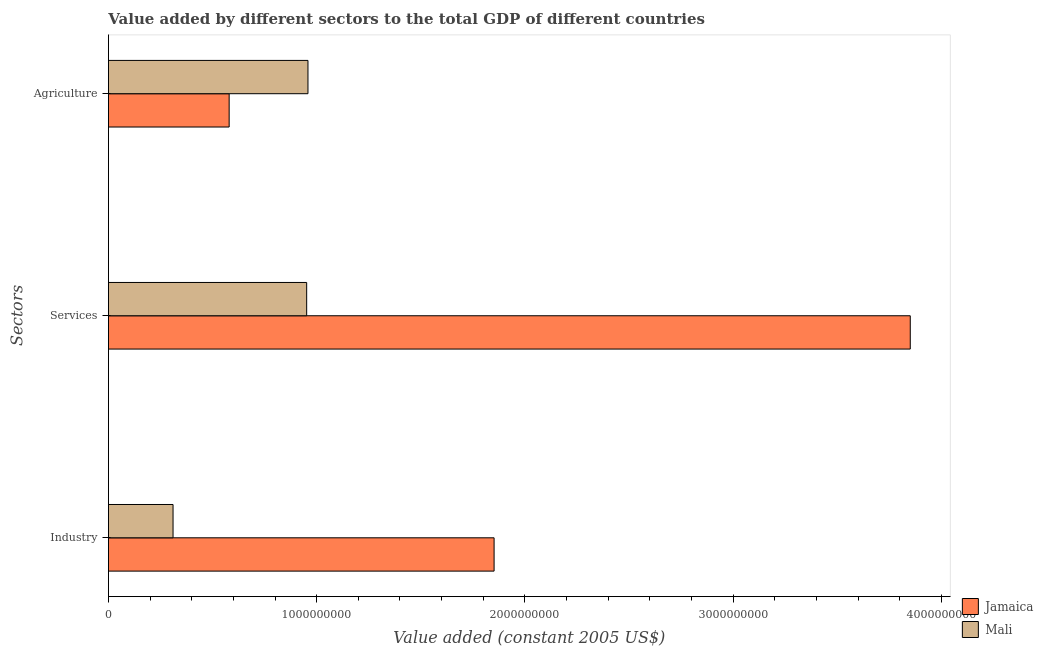Are the number of bars on each tick of the Y-axis equal?
Your answer should be compact. Yes. How many bars are there on the 3rd tick from the bottom?
Offer a terse response. 2. What is the label of the 1st group of bars from the top?
Provide a succinct answer. Agriculture. What is the value added by industrial sector in Jamaica?
Offer a very short reply. 1.85e+09. Across all countries, what is the maximum value added by agricultural sector?
Provide a succinct answer. 9.58e+08. Across all countries, what is the minimum value added by industrial sector?
Give a very brief answer. 3.10e+08. In which country was the value added by agricultural sector maximum?
Your response must be concise. Mali. In which country was the value added by services minimum?
Your response must be concise. Mali. What is the total value added by agricultural sector in the graph?
Your answer should be very brief. 1.54e+09. What is the difference between the value added by services in Jamaica and that in Mali?
Ensure brevity in your answer.  2.90e+09. What is the difference between the value added by agricultural sector in Jamaica and the value added by services in Mali?
Keep it short and to the point. -3.72e+08. What is the average value added by services per country?
Make the answer very short. 2.40e+09. What is the difference between the value added by agricultural sector and value added by industrial sector in Jamaica?
Provide a succinct answer. -1.27e+09. What is the ratio of the value added by agricultural sector in Mali to that in Jamaica?
Ensure brevity in your answer.  1.65. Is the difference between the value added by agricultural sector in Jamaica and Mali greater than the difference between the value added by services in Jamaica and Mali?
Give a very brief answer. No. What is the difference between the highest and the second highest value added by agricultural sector?
Offer a terse response. 3.78e+08. What is the difference between the highest and the lowest value added by agricultural sector?
Ensure brevity in your answer.  3.78e+08. What does the 2nd bar from the top in Agriculture represents?
Make the answer very short. Jamaica. What does the 1st bar from the bottom in Services represents?
Provide a succinct answer. Jamaica. How many bars are there?
Your response must be concise. 6. Are all the bars in the graph horizontal?
Your response must be concise. Yes. How many countries are there in the graph?
Make the answer very short. 2. What is the difference between two consecutive major ticks on the X-axis?
Give a very brief answer. 1.00e+09. Are the values on the major ticks of X-axis written in scientific E-notation?
Your response must be concise. No. Does the graph contain grids?
Keep it short and to the point. No. How many legend labels are there?
Provide a succinct answer. 2. How are the legend labels stacked?
Your response must be concise. Vertical. What is the title of the graph?
Provide a succinct answer. Value added by different sectors to the total GDP of different countries. What is the label or title of the X-axis?
Your response must be concise. Value added (constant 2005 US$). What is the label or title of the Y-axis?
Provide a succinct answer. Sectors. What is the Value added (constant 2005 US$) of Jamaica in Industry?
Your answer should be very brief. 1.85e+09. What is the Value added (constant 2005 US$) in Mali in Industry?
Your response must be concise. 3.10e+08. What is the Value added (constant 2005 US$) in Jamaica in Services?
Make the answer very short. 3.85e+09. What is the Value added (constant 2005 US$) in Mali in Services?
Give a very brief answer. 9.52e+08. What is the Value added (constant 2005 US$) in Jamaica in Agriculture?
Ensure brevity in your answer.  5.80e+08. What is the Value added (constant 2005 US$) in Mali in Agriculture?
Provide a succinct answer. 9.58e+08. Across all Sectors, what is the maximum Value added (constant 2005 US$) of Jamaica?
Keep it short and to the point. 3.85e+09. Across all Sectors, what is the maximum Value added (constant 2005 US$) of Mali?
Your answer should be compact. 9.58e+08. Across all Sectors, what is the minimum Value added (constant 2005 US$) in Jamaica?
Make the answer very short. 5.80e+08. Across all Sectors, what is the minimum Value added (constant 2005 US$) in Mali?
Ensure brevity in your answer.  3.10e+08. What is the total Value added (constant 2005 US$) of Jamaica in the graph?
Offer a terse response. 6.28e+09. What is the total Value added (constant 2005 US$) of Mali in the graph?
Provide a succinct answer. 2.22e+09. What is the difference between the Value added (constant 2005 US$) in Jamaica in Industry and that in Services?
Your answer should be very brief. -2.00e+09. What is the difference between the Value added (constant 2005 US$) of Mali in Industry and that in Services?
Offer a very short reply. -6.42e+08. What is the difference between the Value added (constant 2005 US$) of Jamaica in Industry and that in Agriculture?
Provide a succinct answer. 1.27e+09. What is the difference between the Value added (constant 2005 US$) in Mali in Industry and that in Agriculture?
Your response must be concise. -6.48e+08. What is the difference between the Value added (constant 2005 US$) in Jamaica in Services and that in Agriculture?
Make the answer very short. 3.27e+09. What is the difference between the Value added (constant 2005 US$) of Mali in Services and that in Agriculture?
Offer a terse response. -6.18e+06. What is the difference between the Value added (constant 2005 US$) in Jamaica in Industry and the Value added (constant 2005 US$) in Mali in Services?
Make the answer very short. 9.00e+08. What is the difference between the Value added (constant 2005 US$) of Jamaica in Industry and the Value added (constant 2005 US$) of Mali in Agriculture?
Offer a terse response. 8.94e+08. What is the difference between the Value added (constant 2005 US$) in Jamaica in Services and the Value added (constant 2005 US$) in Mali in Agriculture?
Your answer should be very brief. 2.89e+09. What is the average Value added (constant 2005 US$) in Jamaica per Sectors?
Keep it short and to the point. 2.09e+09. What is the average Value added (constant 2005 US$) of Mali per Sectors?
Provide a succinct answer. 7.40e+08. What is the difference between the Value added (constant 2005 US$) of Jamaica and Value added (constant 2005 US$) of Mali in Industry?
Ensure brevity in your answer.  1.54e+09. What is the difference between the Value added (constant 2005 US$) of Jamaica and Value added (constant 2005 US$) of Mali in Services?
Your response must be concise. 2.90e+09. What is the difference between the Value added (constant 2005 US$) in Jamaica and Value added (constant 2005 US$) in Mali in Agriculture?
Your answer should be very brief. -3.78e+08. What is the ratio of the Value added (constant 2005 US$) in Jamaica in Industry to that in Services?
Keep it short and to the point. 0.48. What is the ratio of the Value added (constant 2005 US$) in Mali in Industry to that in Services?
Provide a short and direct response. 0.33. What is the ratio of the Value added (constant 2005 US$) in Jamaica in Industry to that in Agriculture?
Give a very brief answer. 3.19. What is the ratio of the Value added (constant 2005 US$) of Mali in Industry to that in Agriculture?
Your answer should be very brief. 0.32. What is the ratio of the Value added (constant 2005 US$) in Jamaica in Services to that in Agriculture?
Provide a succinct answer. 6.64. What is the ratio of the Value added (constant 2005 US$) in Mali in Services to that in Agriculture?
Ensure brevity in your answer.  0.99. What is the difference between the highest and the second highest Value added (constant 2005 US$) of Jamaica?
Your answer should be very brief. 2.00e+09. What is the difference between the highest and the second highest Value added (constant 2005 US$) in Mali?
Your response must be concise. 6.18e+06. What is the difference between the highest and the lowest Value added (constant 2005 US$) of Jamaica?
Make the answer very short. 3.27e+09. What is the difference between the highest and the lowest Value added (constant 2005 US$) of Mali?
Provide a succinct answer. 6.48e+08. 